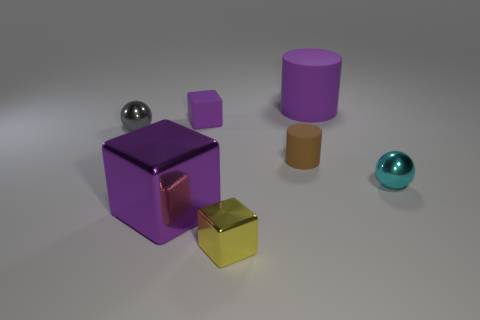Add 2 gray shiny things. How many objects exist? 9 Subtract all big purple blocks. How many blocks are left? 2 Subtract all purple cylinders. How many cylinders are left? 1 Subtract 1 cylinders. How many cylinders are left? 1 Subtract all brown balls. How many purple cubes are left? 2 Subtract all balls. How many objects are left? 5 Subtract all large red shiny spheres. Subtract all small cyan spheres. How many objects are left? 6 Add 3 tiny cyan things. How many tiny cyan things are left? 4 Add 4 metal cylinders. How many metal cylinders exist? 4 Subtract 0 blue balls. How many objects are left? 7 